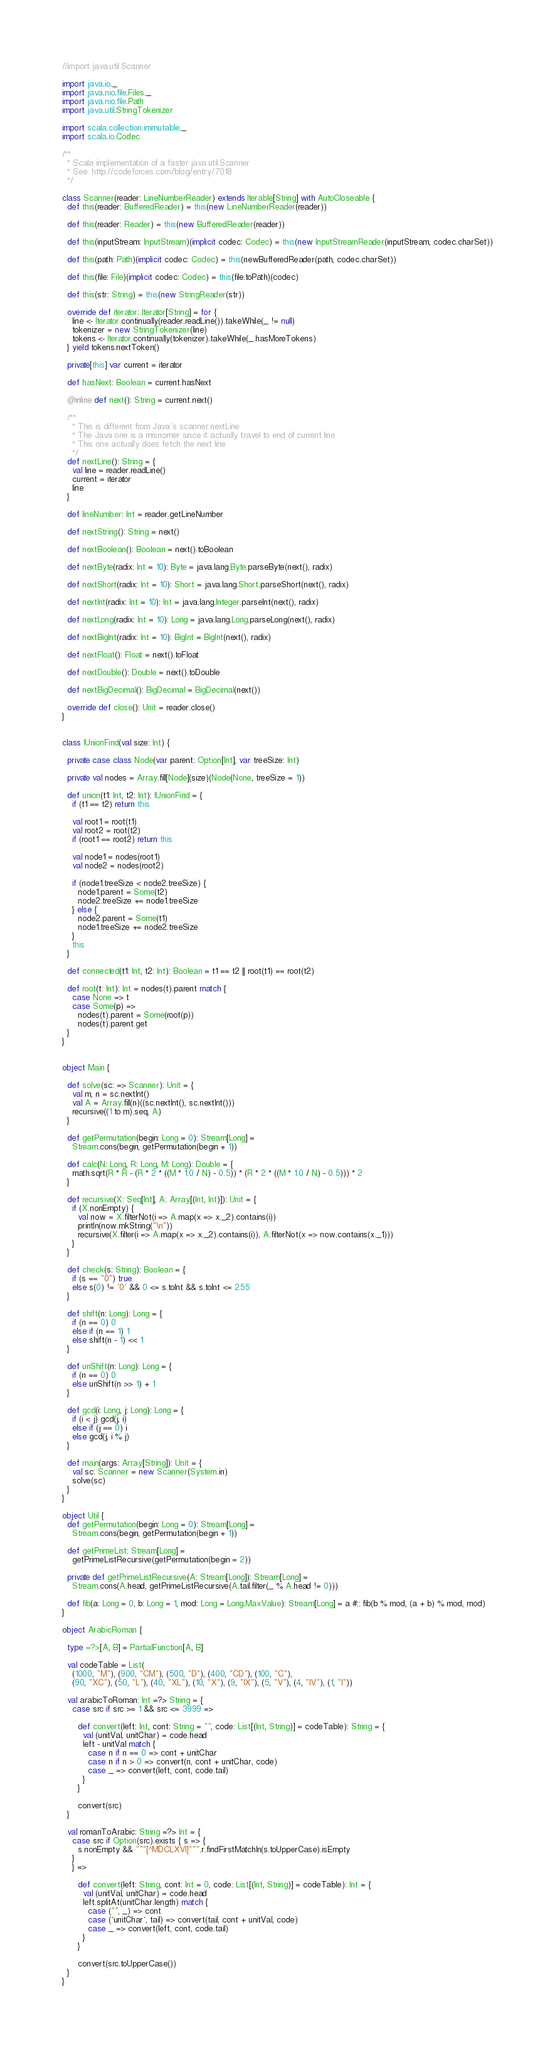Convert code to text. <code><loc_0><loc_0><loc_500><loc_500><_Scala_>//import java.util.Scanner

import java.io._
import java.nio.file.Files._
import java.nio.file.Path
import java.util.StringTokenizer

import scala.collection.immutable._
import scala.io.Codec

/**
  * Scala implementation of a faster java.util.Scanner
  * See: http://codeforces.com/blog/entry/7018
  */

class Scanner(reader: LineNumberReader) extends Iterable[String] with AutoCloseable {
  def this(reader: BufferedReader) = this(new LineNumberReader(reader))

  def this(reader: Reader) = this(new BufferedReader(reader))

  def this(inputStream: InputStream)(implicit codec: Codec) = this(new InputStreamReader(inputStream, codec.charSet))

  def this(path: Path)(implicit codec: Codec) = this(newBufferedReader(path, codec.charSet))

  def this(file: File)(implicit codec: Codec) = this(file.toPath)(codec)

  def this(str: String) = this(new StringReader(str))

  override def iterator: Iterator[String] = for {
    line <- Iterator.continually(reader.readLine()).takeWhile(_ != null)
    tokenizer = new StringTokenizer(line)
    tokens <- Iterator.continually(tokenizer).takeWhile(_.hasMoreTokens)
  } yield tokens.nextToken()

  private[this] var current = iterator

  def hasNext: Boolean = current.hasNext

  @inline def next(): String = current.next()

  /**
    * This is different from Java's scanner.nextLine
    * The Java one is a misnomer since it actually travel to end of current line
    * This one actually does fetch the next line
    */
  def nextLine(): String = {
    val line = reader.readLine()
    current = iterator
    line
  }

  def lineNumber: Int = reader.getLineNumber

  def nextString(): String = next()

  def nextBoolean(): Boolean = next().toBoolean

  def nextByte(radix: Int = 10): Byte = java.lang.Byte.parseByte(next(), radix)

  def nextShort(radix: Int = 10): Short = java.lang.Short.parseShort(next(), radix)

  def nextInt(radix: Int = 10): Int = java.lang.Integer.parseInt(next(), radix)

  def nextLong(radix: Int = 10): Long = java.lang.Long.parseLong(next(), radix)

  def nextBigInt(radix: Int = 10): BigInt = BigInt(next(), radix)

  def nextFloat(): Float = next().toFloat

  def nextDouble(): Double = next().toDouble

  def nextBigDecimal(): BigDecimal = BigDecimal(next())

  override def close(): Unit = reader.close()
}


class IUnionFind(val size: Int) {

  private case class Node(var parent: Option[Int], var treeSize: Int)

  private val nodes = Array.fill[Node](size)(Node(None, treeSize = 1))

  def union(t1: Int, t2: Int): IUnionFind = {
    if (t1 == t2) return this

    val root1 = root(t1)
    val root2 = root(t2)
    if (root1 == root2) return this

    val node1 = nodes(root1)
    val node2 = nodes(root2)

    if (node1.treeSize < node2.treeSize) {
      node1.parent = Some(t2)
      node2.treeSize += node1.treeSize
    } else {
      node2.parent = Some(t1)
      node1.treeSize += node2.treeSize
    }
    this
  }

  def connected(t1: Int, t2: Int): Boolean = t1 == t2 || root(t1) == root(t2)

  def root(t: Int): Int = nodes(t).parent match {
    case None => t
    case Some(p) =>
      nodes(t).parent = Some(root(p))
      nodes(t).parent.get
  }
}


object Main {

  def solve(sc: => Scanner): Unit = {
    val m, n = sc.nextInt()
    val A = Array.fill(n)((sc.nextInt(), sc.nextInt()))
    recursive((1 to m).seq, A)
  }

  def getPermutation(begin: Long = 0): Stream[Long] =
    Stream.cons(begin, getPermutation(begin + 1))

  def calc(N: Long, R: Long, M: Long): Double = {
    math.sqrt(R * R - (R * 2 * ((M * 1.0 / N) - 0.5)) * (R * 2 * ((M * 1.0 / N) - 0.5))) * 2
  }

  def recursive(X: Seq[Int], A: Array[(Int, Int)]): Unit = {
    if (X.nonEmpty) {
      val now = X.filterNot(i => A.map(x => x._2).contains(i))
      println(now.mkString("\n"))
      recursive(X.filter(i => A.map(x => x._2).contains(i)), A.filterNot(x => now.contains(x._1)))
    }
  }

  def check(s: String): Boolean = {
    if (s == "0") true
    else s(0) != '0' && 0 <= s.toInt && s.toInt <= 255
  }

  def shift(n: Long): Long = {
    if (n == 0) 0
    else if (n == 1) 1
    else shift(n - 1) << 1
  }

  def unShift(n: Long): Long = {
    if (n == 0) 0
    else unShift(n >> 1) + 1
  }

  def gcd(i: Long, j: Long): Long = {
    if (i < j) gcd(j, i)
    else if (j == 0) i
    else gcd(j, i % j)
  }

  def main(args: Array[String]): Unit = {
    val sc: Scanner = new Scanner(System.in)
    solve(sc)
  }
}

object Util {
  def getPermutation(begin: Long = 0): Stream[Long] =
    Stream.cons(begin, getPermutation(begin + 1))

  def getPrimeList: Stream[Long] =
    getPrimeListRecursive(getPermutation(begin = 2))

  private def getPrimeListRecursive(A: Stream[Long]): Stream[Long] =
    Stream.cons(A.head, getPrimeListRecursive(A.tail.filter(_ % A.head != 0)))

  def fib(a: Long = 0, b: Long = 1, mod: Long = Long.MaxValue): Stream[Long] = a #:: fib(b % mod, (a + b) % mod, mod)
}

object ArabicRoman {

  type =?>[A, B] = PartialFunction[A, B]

  val codeTable = List(
    (1000, "M"), (900, "CM"), (500, "D"), (400, "CD"), (100, "C"),
    (90, "XC"), (50, "L"), (40, "XL"), (10, "X"), (9, "IX"), (5, "V"), (4, "IV"), (1, "I"))

  val arabicToRoman: Int =?> String = {
    case src if src >= 1 && src <= 3999 =>

      def convert(left: Int, cont: String = "", code: List[(Int, String)] = codeTable): String = {
        val (unitVal, unitChar) = code.head
        left - unitVal match {
          case n if n == 0 => cont + unitChar
          case n if n > 0 => convert(n, cont + unitChar, code)
          case _ => convert(left, cont, code.tail)
        }
      }

      convert(src)
  }

  val romanToArabic: String =?> Int = {
    case src if Option(src).exists { s => {
      s.nonEmpty && """[^MDCLXVI]""".r.findFirstMatchIn(s.toUpperCase).isEmpty
    }
    } =>

      def convert(left: String, cont: Int = 0, code: List[(Int, String)] = codeTable): Int = {
        val (unitVal, unitChar) = code.head
        left.splitAt(unitChar.length) match {
          case ("", _) => cont
          case (`unitChar`, tail) => convert(tail, cont + unitVal, code)
          case _ => convert(left, cont, code.tail)
        }
      }

      convert(src.toUpperCase())
  }
}
</code> 